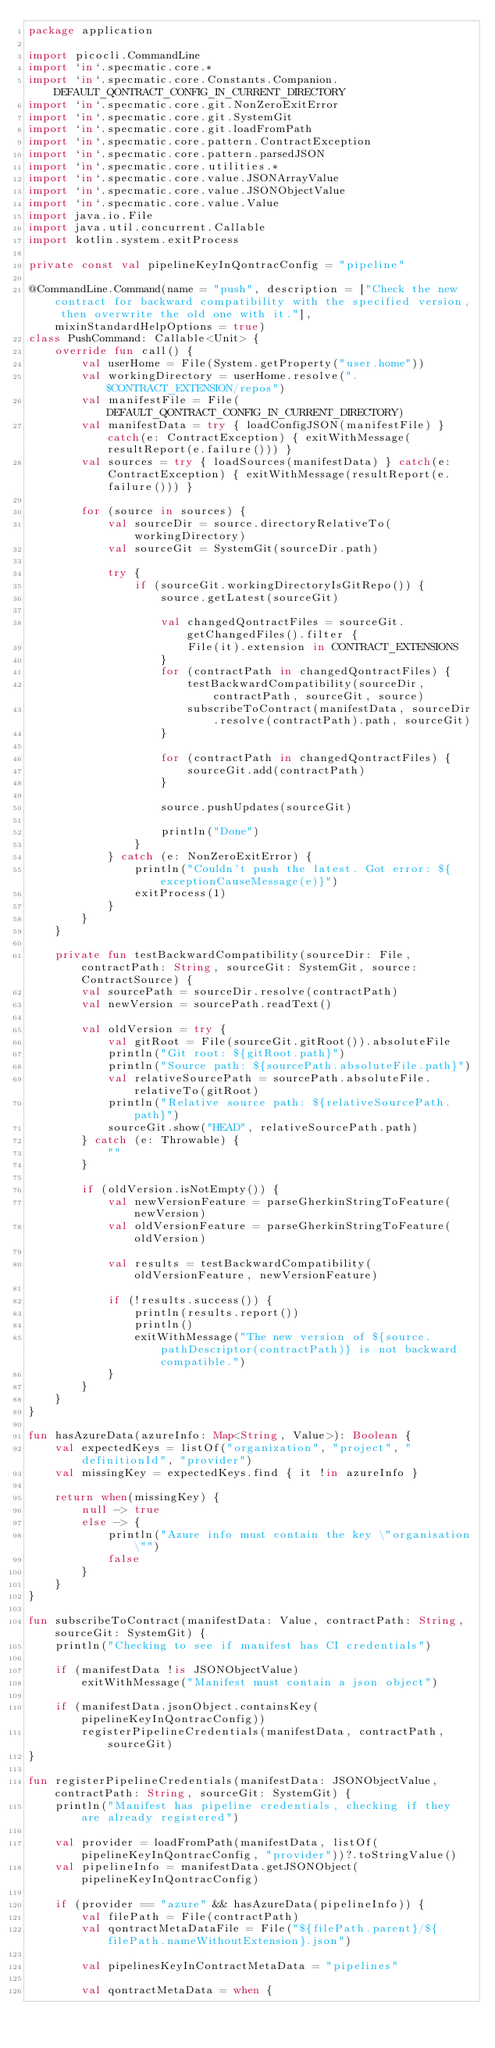<code> <loc_0><loc_0><loc_500><loc_500><_Kotlin_>package application

import picocli.CommandLine
import `in`.specmatic.core.*
import `in`.specmatic.core.Constants.Companion.DEFAULT_QONTRACT_CONFIG_IN_CURRENT_DIRECTORY
import `in`.specmatic.core.git.NonZeroExitError
import `in`.specmatic.core.git.SystemGit
import `in`.specmatic.core.git.loadFromPath
import `in`.specmatic.core.pattern.ContractException
import `in`.specmatic.core.pattern.parsedJSON
import `in`.specmatic.core.utilities.*
import `in`.specmatic.core.value.JSONArrayValue
import `in`.specmatic.core.value.JSONObjectValue
import `in`.specmatic.core.value.Value
import java.io.File
import java.util.concurrent.Callable
import kotlin.system.exitProcess

private const val pipelineKeyInQontracConfig = "pipeline"

@CommandLine.Command(name = "push", description = ["Check the new contract for backward compatibility with the specified version, then overwrite the old one with it."], mixinStandardHelpOptions = true)
class PushCommand: Callable<Unit> {
    override fun call() {
        val userHome = File(System.getProperty("user.home"))
        val workingDirectory = userHome.resolve(".$CONTRACT_EXTENSION/repos")
        val manifestFile = File(DEFAULT_QONTRACT_CONFIG_IN_CURRENT_DIRECTORY)
        val manifestData = try { loadConfigJSON(manifestFile) } catch(e: ContractException) { exitWithMessage(resultReport(e.failure())) }
        val sources = try { loadSources(manifestData) } catch(e: ContractException) { exitWithMessage(resultReport(e.failure())) }

        for (source in sources) {
            val sourceDir = source.directoryRelativeTo(workingDirectory)
            val sourceGit = SystemGit(sourceDir.path)

            try {
                if (sourceGit.workingDirectoryIsGitRepo()) {
                    source.getLatest(sourceGit)

                    val changedQontractFiles = sourceGit.getChangedFiles().filter {
                        File(it).extension in CONTRACT_EXTENSIONS
                    }
                    for (contractPath in changedQontractFiles) {
                        testBackwardCompatibility(sourceDir, contractPath, sourceGit, source)
                        subscribeToContract(manifestData, sourceDir.resolve(contractPath).path, sourceGit)
                    }

                    for (contractPath in changedQontractFiles) {
                        sourceGit.add(contractPath)
                    }

                    source.pushUpdates(sourceGit)

                    println("Done")
                }
            } catch (e: NonZeroExitError) {
                println("Couldn't push the latest. Got error: ${exceptionCauseMessage(e)}")
                exitProcess(1)
            }
        }
    }

    private fun testBackwardCompatibility(sourceDir: File, contractPath: String, sourceGit: SystemGit, source: ContractSource) {
        val sourcePath = sourceDir.resolve(contractPath)
        val newVersion = sourcePath.readText()

        val oldVersion = try {
            val gitRoot = File(sourceGit.gitRoot()).absoluteFile
            println("Git root: ${gitRoot.path}")
            println("Source path: ${sourcePath.absoluteFile.path}")
            val relativeSourcePath = sourcePath.absoluteFile.relativeTo(gitRoot)
            println("Relative source path: ${relativeSourcePath.path}")
            sourceGit.show("HEAD", relativeSourcePath.path)
        } catch (e: Throwable) {
            ""
        }

        if (oldVersion.isNotEmpty()) {
            val newVersionFeature = parseGherkinStringToFeature(newVersion)
            val oldVersionFeature = parseGherkinStringToFeature(oldVersion)

            val results = testBackwardCompatibility(oldVersionFeature, newVersionFeature)

            if (!results.success()) {
                println(results.report())
                println()
                exitWithMessage("The new version of ${source.pathDescriptor(contractPath)} is not backward compatible.")
            }
        }
    }
}

fun hasAzureData(azureInfo: Map<String, Value>): Boolean {
    val expectedKeys = listOf("organization", "project", "definitionId", "provider")
    val missingKey = expectedKeys.find { it !in azureInfo }

    return when(missingKey) {
        null -> true
        else -> {
            println("Azure info must contain the key \"organisation\"")
            false
        }
    }
}

fun subscribeToContract(manifestData: Value, contractPath: String, sourceGit: SystemGit) {
    println("Checking to see if manifest has CI credentials")

    if (manifestData !is JSONObjectValue)
        exitWithMessage("Manifest must contain a json object")

    if (manifestData.jsonObject.containsKey(pipelineKeyInQontracConfig))
        registerPipelineCredentials(manifestData, contractPath, sourceGit)
}

fun registerPipelineCredentials(manifestData: JSONObjectValue, contractPath: String, sourceGit: SystemGit) {
    println("Manifest has pipeline credentials, checking if they are already registered")

    val provider = loadFromPath(manifestData, listOf(pipelineKeyInQontracConfig, "provider"))?.toStringValue()
    val pipelineInfo = manifestData.getJSONObject(pipelineKeyInQontracConfig)

    if (provider == "azure" && hasAzureData(pipelineInfo)) {
        val filePath = File(contractPath)
        val qontractMetaDataFile = File("${filePath.parent}/${filePath.nameWithoutExtension}.json")

        val pipelinesKeyInContractMetaData = "pipelines"

        val qontractMetaData = when {</code> 